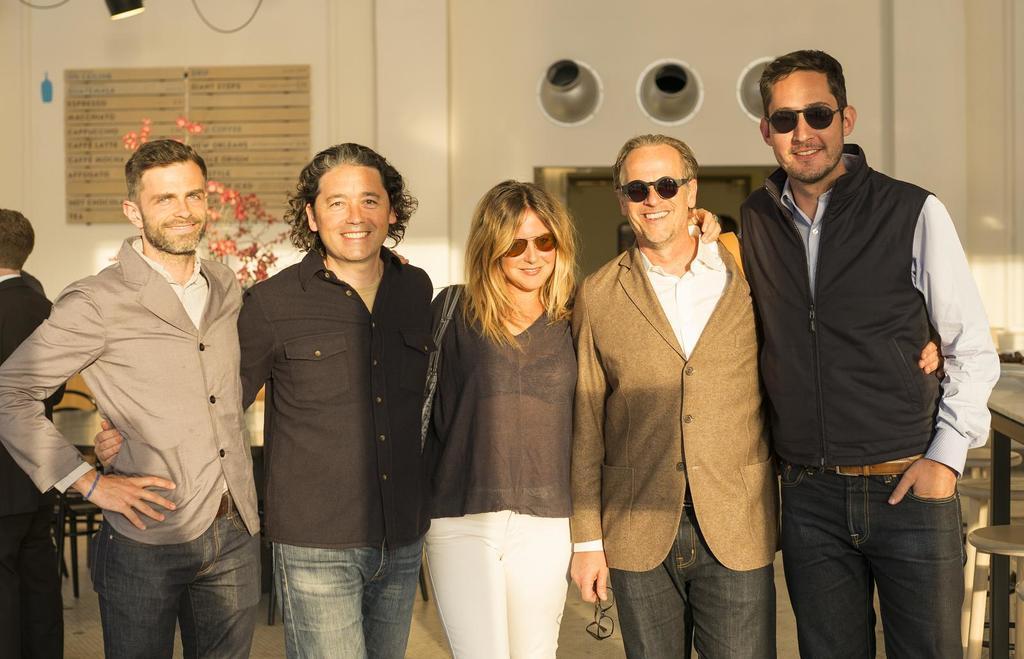Describe this image in one or two sentences. In this image there are a few people standing with a smile on their face is posing for the camera, behind them there are tables and chairs, on the wall there is a name board. 